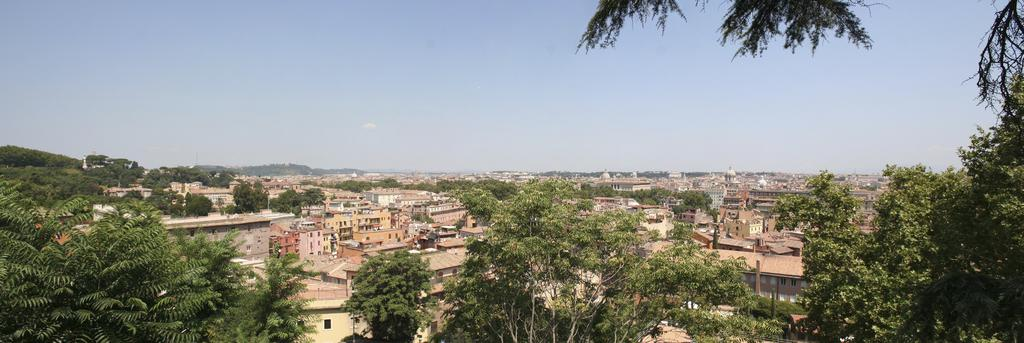What type of structures can be seen in the image? There is a group of buildings in the image. What type of vegetation is present in the image? There is a group of trees in the image. What can be seen in the background of the image? The sky is visible in the background of the image. Where is the swing located in the image? There is no swing present in the image. What type of plants are growing in the basin in the image? There is no basin or plants growing in a basin present in the image. 